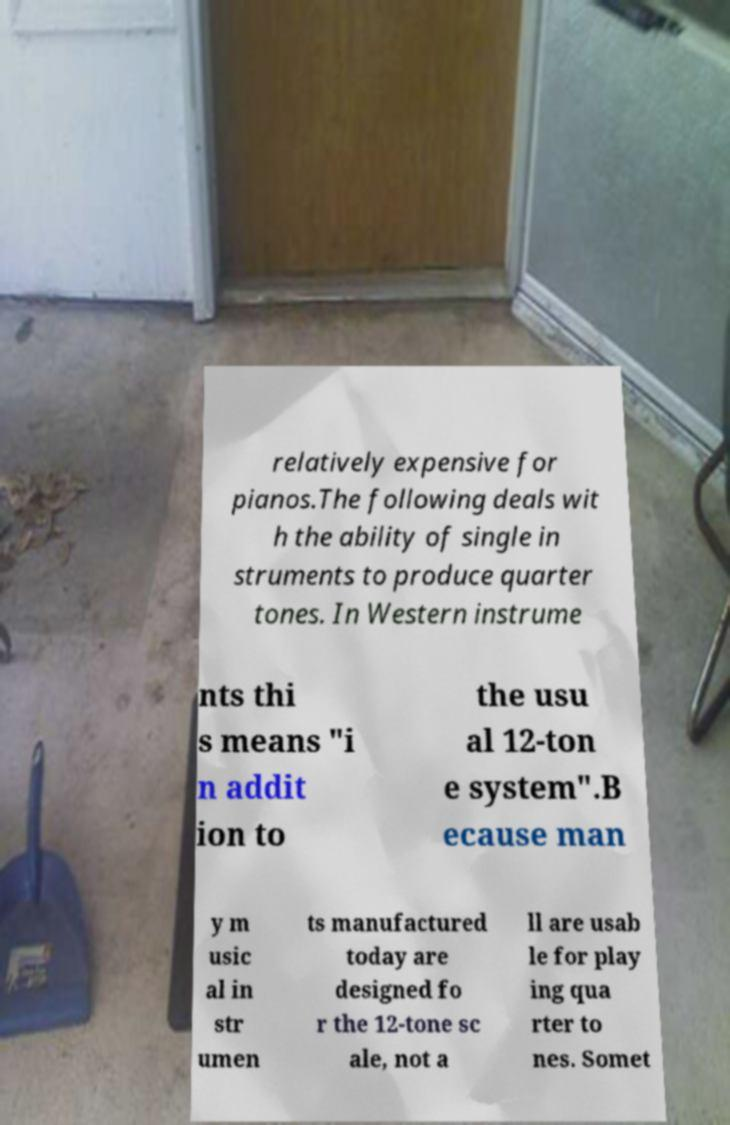Please read and relay the text visible in this image. What does it say? relatively expensive for pianos.The following deals wit h the ability of single in struments to produce quarter tones. In Western instrume nts thi s means "i n addit ion to the usu al 12-ton e system".B ecause man y m usic al in str umen ts manufactured today are designed fo r the 12-tone sc ale, not a ll are usab le for play ing qua rter to nes. Somet 